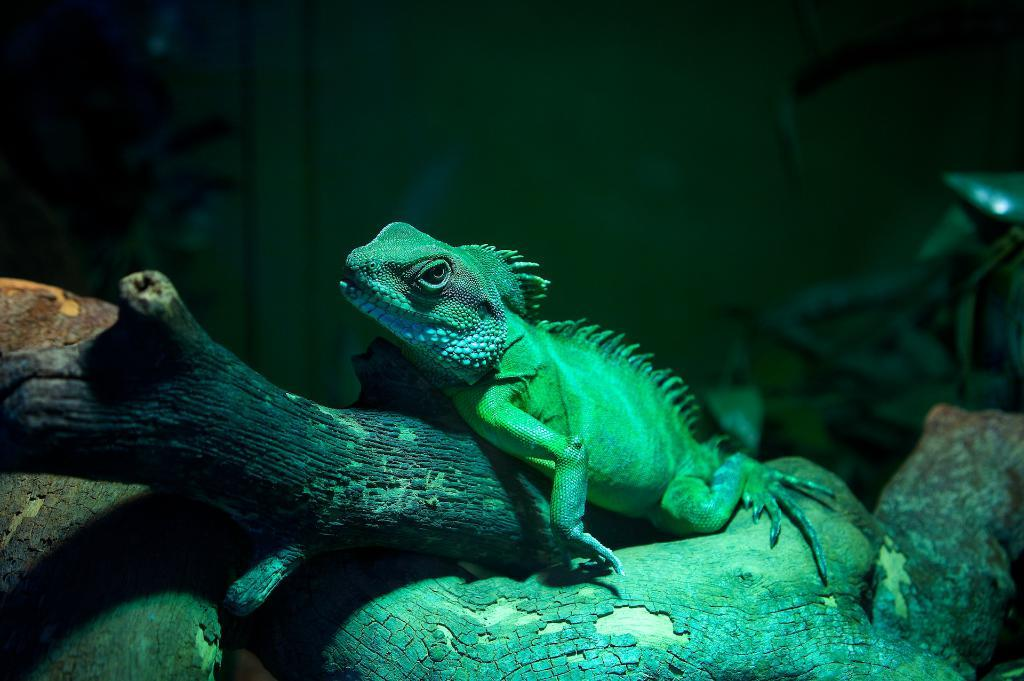What type of animal is in the image? There is a Green iguana in the image. Where is the Green iguana located? The Green iguana is on a branch of a tree. What type of muscle can be seen in the image? There is no muscle visible in the image; it features a Green iguana on a tree branch. How many eggs are present in the image? There are no eggs present in the image; it features a Green iguana on a tree branch. 